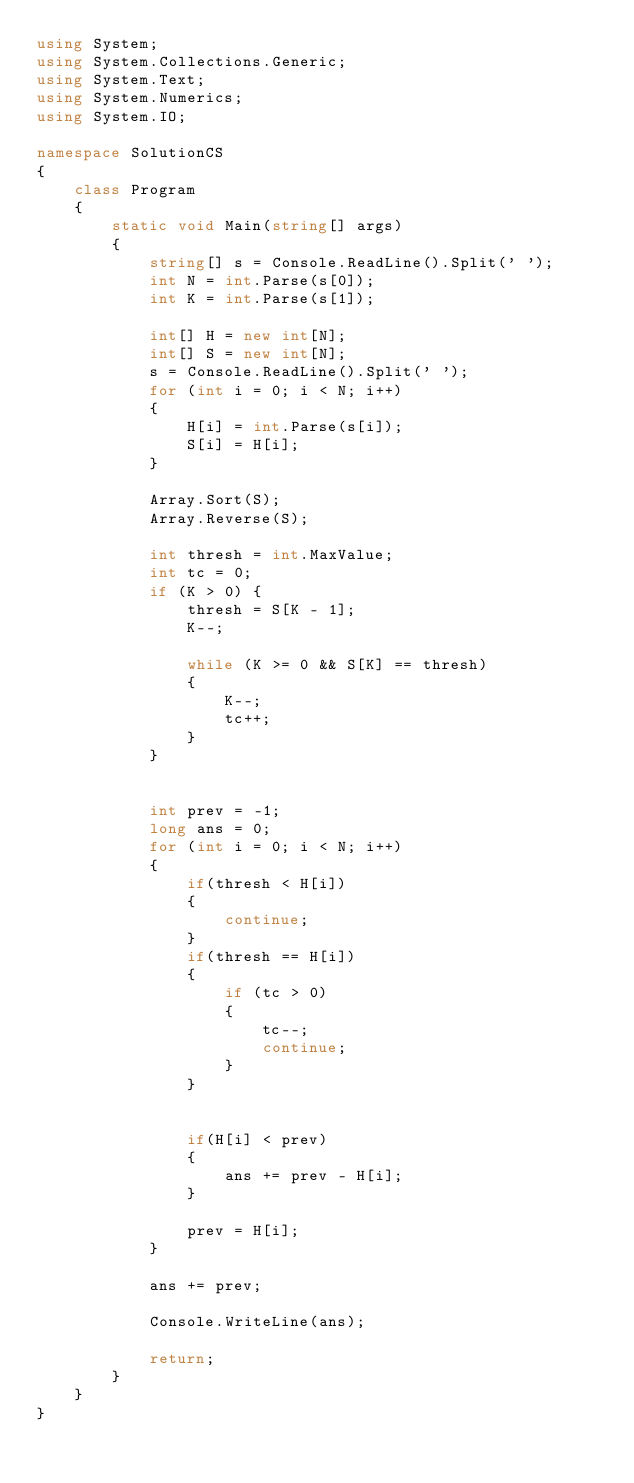<code> <loc_0><loc_0><loc_500><loc_500><_C#_>using System;
using System.Collections.Generic;
using System.Text;
using System.Numerics;
using System.IO;

namespace SolutionCS
{
    class Program
    {
        static void Main(string[] args)
        {
            string[] s = Console.ReadLine().Split(' ');
            int N = int.Parse(s[0]);
            int K = int.Parse(s[1]);

            int[] H = new int[N];
            int[] S = new int[N];
            s = Console.ReadLine().Split(' ');
            for (int i = 0; i < N; i++)
            {
                H[i] = int.Parse(s[i]);
                S[i] = H[i];
            }

            Array.Sort(S);
            Array.Reverse(S);

            int thresh = int.MaxValue;
            int tc = 0;
            if (K > 0) {
                thresh = S[K - 1];
                K--;

                while (K >= 0 && S[K] == thresh)
                {
                    K--;
                    tc++;
                }
            }


            int prev = -1;
            long ans = 0;
            for (int i = 0; i < N; i++)
            {
                if(thresh < H[i])
                {
                    continue;
                }
                if(thresh == H[i])
                {
                    if (tc > 0)
                    {
                        tc--;
                        continue;
                    }
                }


                if(H[i] < prev)
                {
                    ans += prev - H[i];
                }

                prev = H[i];
            }

            ans += prev;

            Console.WriteLine(ans);

            return;
        }
    }
}

</code> 